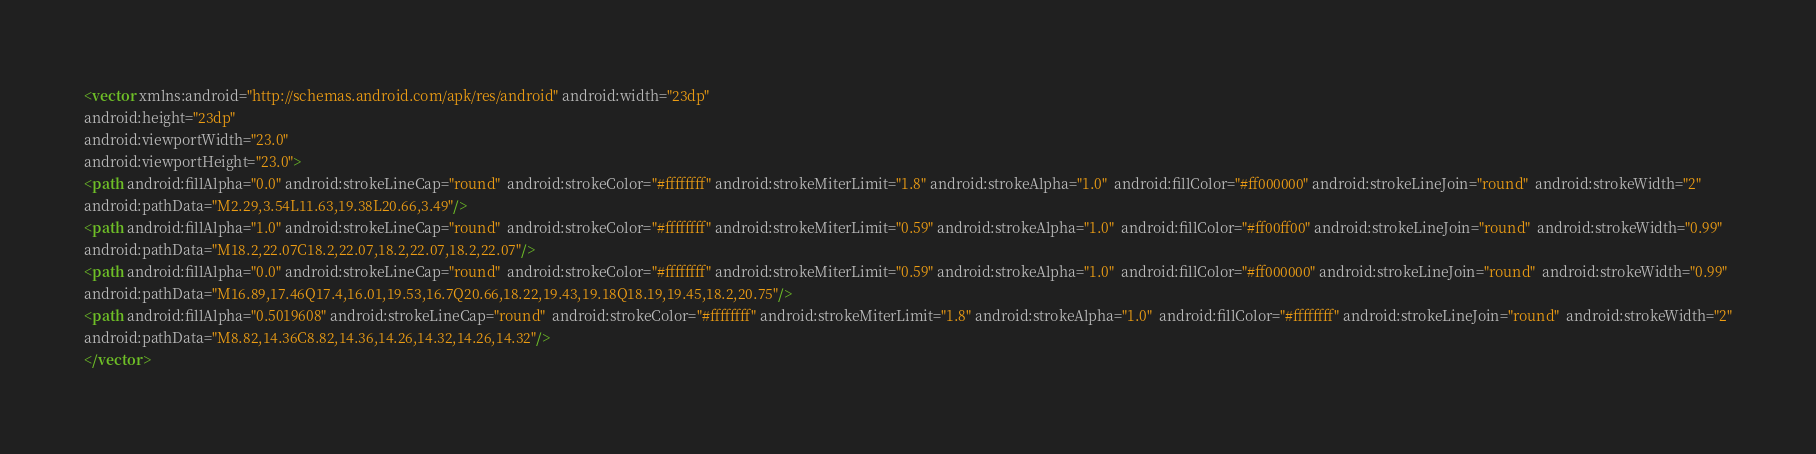<code> <loc_0><loc_0><loc_500><loc_500><_XML_><vector xmlns:android="http://schemas.android.com/apk/res/android" android:width="23dp"
android:height="23dp"
android:viewportWidth="23.0"
android:viewportHeight="23.0">
<path android:fillAlpha="0.0" android:strokeLineCap="round"  android:strokeColor="#ffffffff" android:strokeMiterLimit="1.8" android:strokeAlpha="1.0"  android:fillColor="#ff000000" android:strokeLineJoin="round"  android:strokeWidth="2"
android:pathData="M2.29,3.54L11.63,19.38L20.66,3.49"/>
<path android:fillAlpha="1.0" android:strokeLineCap="round"  android:strokeColor="#ffffffff" android:strokeMiterLimit="0.59" android:strokeAlpha="1.0"  android:fillColor="#ff00ff00" android:strokeLineJoin="round"  android:strokeWidth="0.99"
android:pathData="M18.2,22.07C18.2,22.07,18.2,22.07,18.2,22.07"/>
<path android:fillAlpha="0.0" android:strokeLineCap="round"  android:strokeColor="#ffffffff" android:strokeMiterLimit="0.59" android:strokeAlpha="1.0"  android:fillColor="#ff000000" android:strokeLineJoin="round"  android:strokeWidth="0.99"
android:pathData="M16.89,17.46Q17.4,16.01,19.53,16.7Q20.66,18.22,19.43,19.18Q18.19,19.45,18.2,20.75"/>
<path android:fillAlpha="0.5019608" android:strokeLineCap="round"  android:strokeColor="#ffffffff" android:strokeMiterLimit="1.8" android:strokeAlpha="1.0"  android:fillColor="#ffffffff" android:strokeLineJoin="round"  android:strokeWidth="2"
android:pathData="M8.82,14.36C8.82,14.36,14.26,14.32,14.26,14.32"/>
</vector></code> 